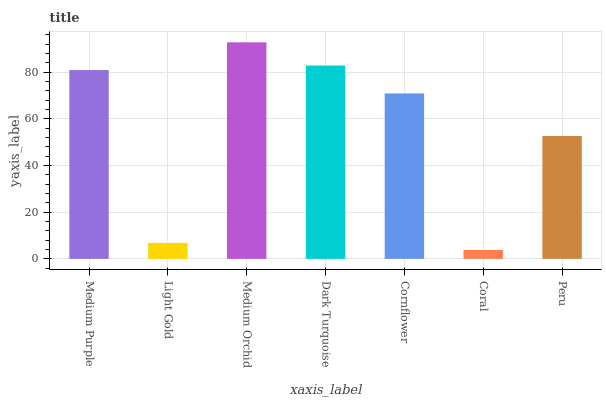Is Coral the minimum?
Answer yes or no. Yes. Is Medium Orchid the maximum?
Answer yes or no. Yes. Is Light Gold the minimum?
Answer yes or no. No. Is Light Gold the maximum?
Answer yes or no. No. Is Medium Purple greater than Light Gold?
Answer yes or no. Yes. Is Light Gold less than Medium Purple?
Answer yes or no. Yes. Is Light Gold greater than Medium Purple?
Answer yes or no. No. Is Medium Purple less than Light Gold?
Answer yes or no. No. Is Cornflower the high median?
Answer yes or no. Yes. Is Cornflower the low median?
Answer yes or no. Yes. Is Coral the high median?
Answer yes or no. No. Is Medium Orchid the low median?
Answer yes or no. No. 